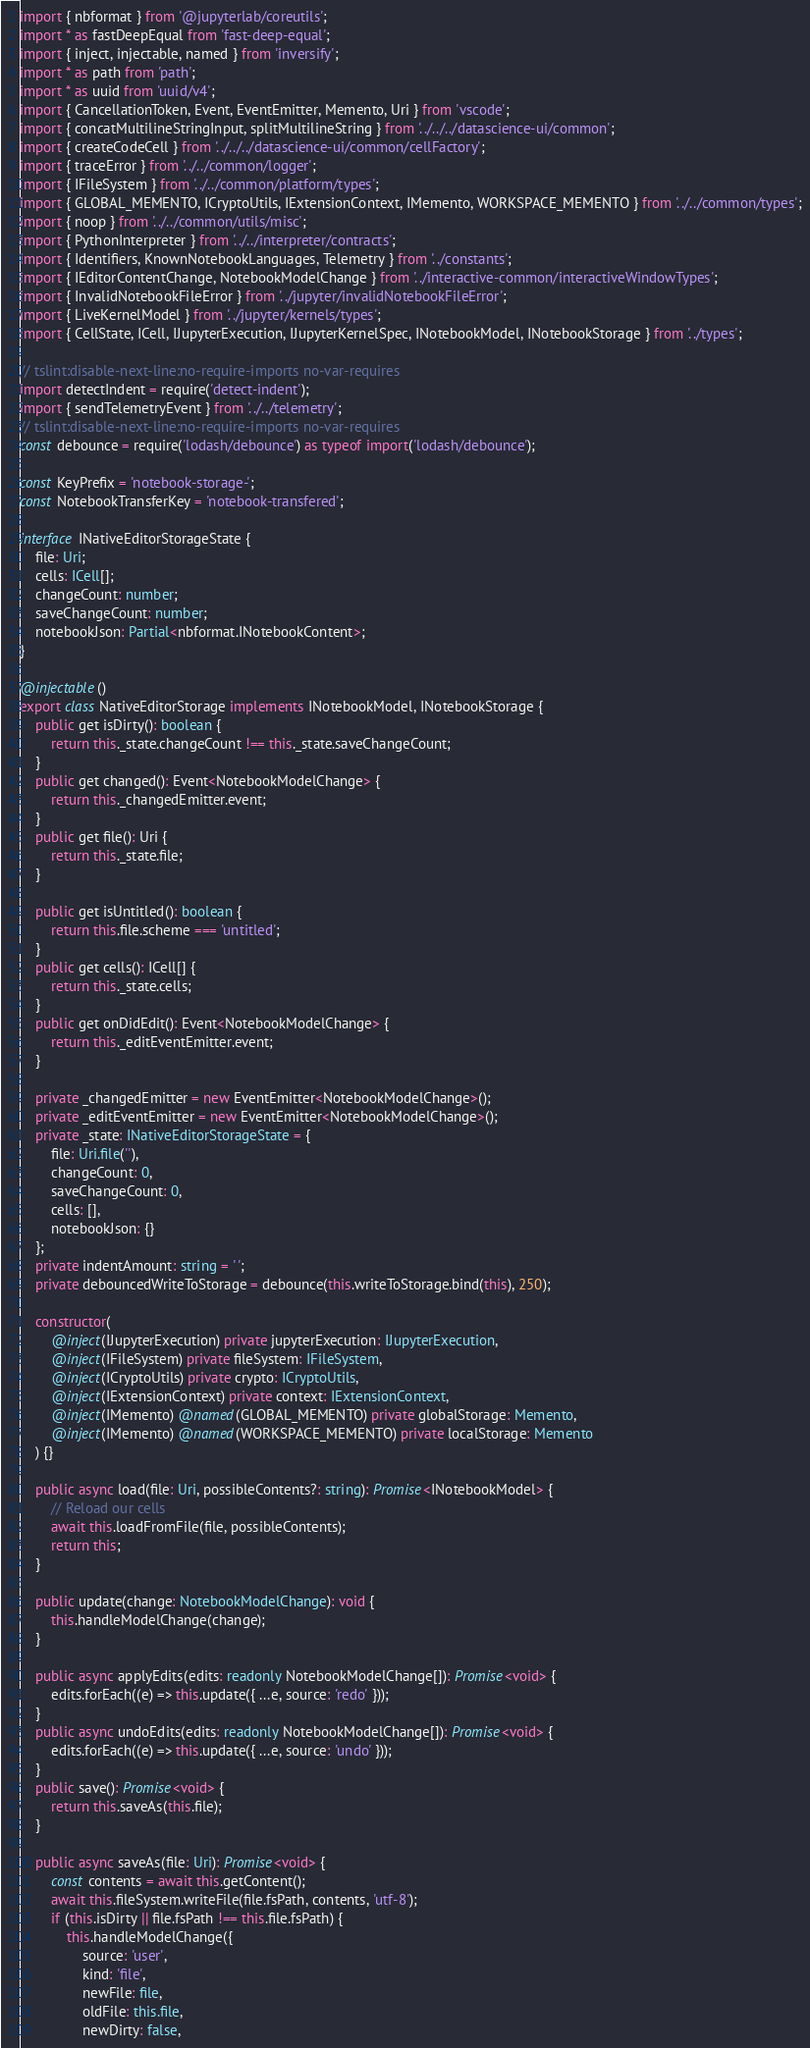<code> <loc_0><loc_0><loc_500><loc_500><_TypeScript_>import { nbformat } from '@jupyterlab/coreutils';
import * as fastDeepEqual from 'fast-deep-equal';
import { inject, injectable, named } from 'inversify';
import * as path from 'path';
import * as uuid from 'uuid/v4';
import { CancellationToken, Event, EventEmitter, Memento, Uri } from 'vscode';
import { concatMultilineStringInput, splitMultilineString } from '../../../datascience-ui/common';
import { createCodeCell } from '../../../datascience-ui/common/cellFactory';
import { traceError } from '../../common/logger';
import { IFileSystem } from '../../common/platform/types';
import { GLOBAL_MEMENTO, ICryptoUtils, IExtensionContext, IMemento, WORKSPACE_MEMENTO } from '../../common/types';
import { noop } from '../../common/utils/misc';
import { PythonInterpreter } from '../../interpreter/contracts';
import { Identifiers, KnownNotebookLanguages, Telemetry } from '../constants';
import { IEditorContentChange, NotebookModelChange } from '../interactive-common/interactiveWindowTypes';
import { InvalidNotebookFileError } from '../jupyter/invalidNotebookFileError';
import { LiveKernelModel } from '../jupyter/kernels/types';
import { CellState, ICell, IJupyterExecution, IJupyterKernelSpec, INotebookModel, INotebookStorage } from '../types';

// tslint:disable-next-line:no-require-imports no-var-requires
import detectIndent = require('detect-indent');
import { sendTelemetryEvent } from '../../telemetry';
// tslint:disable-next-line:no-require-imports no-var-requires
const debounce = require('lodash/debounce') as typeof import('lodash/debounce');

const KeyPrefix = 'notebook-storage-';
const NotebookTransferKey = 'notebook-transfered';

interface INativeEditorStorageState {
    file: Uri;
    cells: ICell[];
    changeCount: number;
    saveChangeCount: number;
    notebookJson: Partial<nbformat.INotebookContent>;
}

@injectable()
export class NativeEditorStorage implements INotebookModel, INotebookStorage {
    public get isDirty(): boolean {
        return this._state.changeCount !== this._state.saveChangeCount;
    }
    public get changed(): Event<NotebookModelChange> {
        return this._changedEmitter.event;
    }
    public get file(): Uri {
        return this._state.file;
    }

    public get isUntitled(): boolean {
        return this.file.scheme === 'untitled';
    }
    public get cells(): ICell[] {
        return this._state.cells;
    }
    public get onDidEdit(): Event<NotebookModelChange> {
        return this._editEventEmitter.event;
    }

    private _changedEmitter = new EventEmitter<NotebookModelChange>();
    private _editEventEmitter = new EventEmitter<NotebookModelChange>();
    private _state: INativeEditorStorageState = {
        file: Uri.file(''),
        changeCount: 0,
        saveChangeCount: 0,
        cells: [],
        notebookJson: {}
    };
    private indentAmount: string = ' ';
    private debouncedWriteToStorage = debounce(this.writeToStorage.bind(this), 250);

    constructor(
        @inject(IJupyterExecution) private jupyterExecution: IJupyterExecution,
        @inject(IFileSystem) private fileSystem: IFileSystem,
        @inject(ICryptoUtils) private crypto: ICryptoUtils,
        @inject(IExtensionContext) private context: IExtensionContext,
        @inject(IMemento) @named(GLOBAL_MEMENTO) private globalStorage: Memento,
        @inject(IMemento) @named(WORKSPACE_MEMENTO) private localStorage: Memento
    ) {}

    public async load(file: Uri, possibleContents?: string): Promise<INotebookModel> {
        // Reload our cells
        await this.loadFromFile(file, possibleContents);
        return this;
    }

    public update(change: NotebookModelChange): void {
        this.handleModelChange(change);
    }

    public async applyEdits(edits: readonly NotebookModelChange[]): Promise<void> {
        edits.forEach((e) => this.update({ ...e, source: 'redo' }));
    }
    public async undoEdits(edits: readonly NotebookModelChange[]): Promise<void> {
        edits.forEach((e) => this.update({ ...e, source: 'undo' }));
    }
    public save(): Promise<void> {
        return this.saveAs(this.file);
    }

    public async saveAs(file: Uri): Promise<void> {
        const contents = await this.getContent();
        await this.fileSystem.writeFile(file.fsPath, contents, 'utf-8');
        if (this.isDirty || file.fsPath !== this.file.fsPath) {
            this.handleModelChange({
                source: 'user',
                kind: 'file',
                newFile: file,
                oldFile: this.file,
                newDirty: false,</code> 